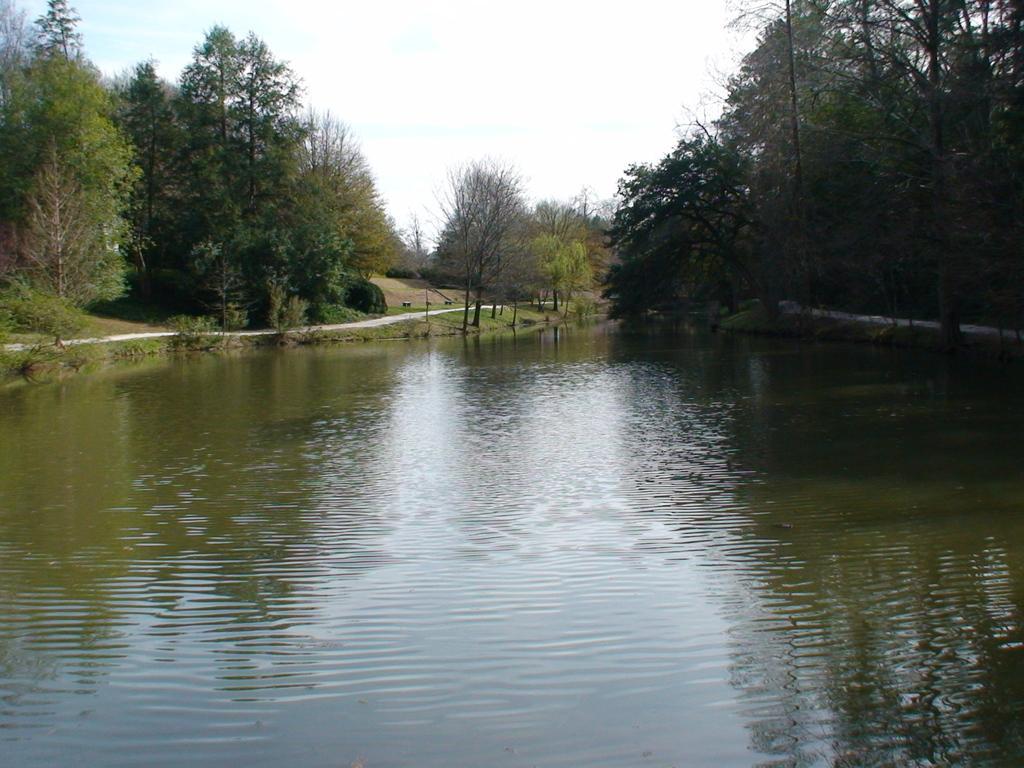Please provide a concise description of this image. In this image we can see some trees and grass. In the background of the image there is the sky. At the bottom of the image there is water. On the water we can see some reflections. 